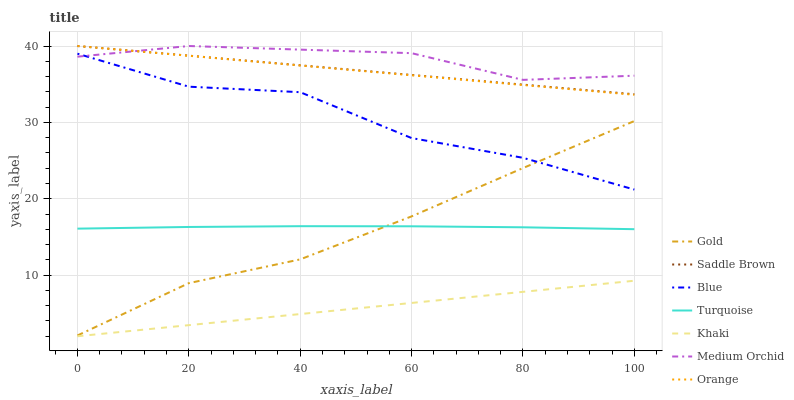Does Khaki have the minimum area under the curve?
Answer yes or no. Yes. Does Medium Orchid have the maximum area under the curve?
Answer yes or no. Yes. Does Turquoise have the minimum area under the curve?
Answer yes or no. No. Does Turquoise have the maximum area under the curve?
Answer yes or no. No. Is Khaki the smoothest?
Answer yes or no. Yes. Is Blue the roughest?
Answer yes or no. Yes. Is Turquoise the smoothest?
Answer yes or no. No. Is Turquoise the roughest?
Answer yes or no. No. Does Turquoise have the lowest value?
Answer yes or no. No. Does Turquoise have the highest value?
Answer yes or no. No. Is Khaki less than Medium Orchid?
Answer yes or no. Yes. Is Orange greater than Gold?
Answer yes or no. Yes. Does Khaki intersect Medium Orchid?
Answer yes or no. No. 